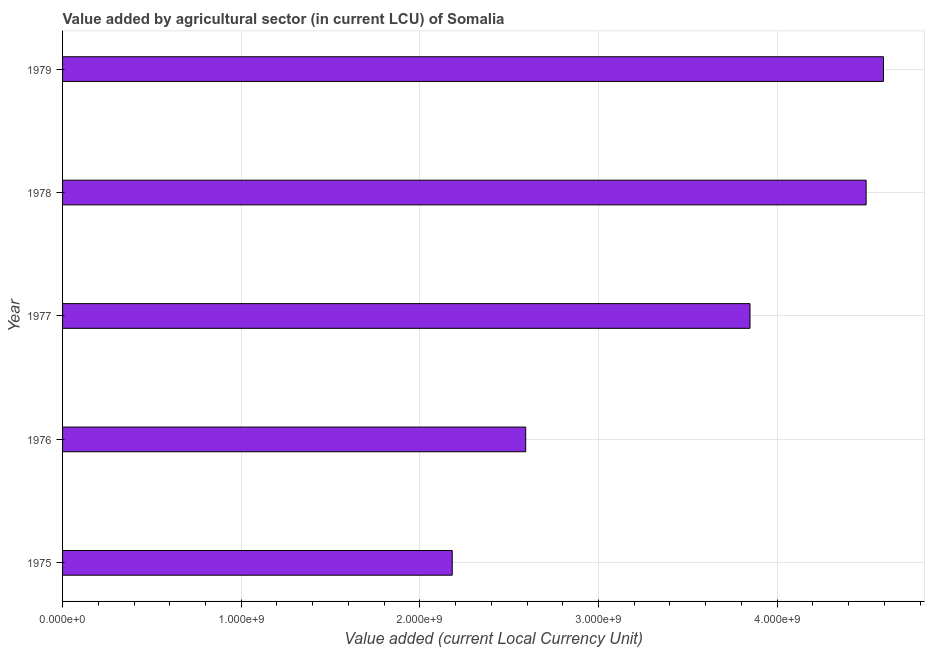What is the title of the graph?
Provide a succinct answer. Value added by agricultural sector (in current LCU) of Somalia. What is the label or title of the X-axis?
Offer a very short reply. Value added (current Local Currency Unit). What is the label or title of the Y-axis?
Offer a terse response. Year. What is the value added by agriculture sector in 1979?
Make the answer very short. 4.59e+09. Across all years, what is the maximum value added by agriculture sector?
Provide a succinct answer. 4.59e+09. Across all years, what is the minimum value added by agriculture sector?
Provide a short and direct response. 2.18e+09. In which year was the value added by agriculture sector maximum?
Your answer should be very brief. 1979. In which year was the value added by agriculture sector minimum?
Give a very brief answer. 1975. What is the sum of the value added by agriculture sector?
Your answer should be very brief. 1.77e+1. What is the difference between the value added by agriculture sector in 1977 and 1979?
Make the answer very short. -7.47e+08. What is the average value added by agriculture sector per year?
Provide a short and direct response. 3.54e+09. What is the median value added by agriculture sector?
Ensure brevity in your answer.  3.85e+09. Do a majority of the years between 1977 and 1976 (inclusive) have value added by agriculture sector greater than 1000000000 LCU?
Your response must be concise. No. What is the ratio of the value added by agriculture sector in 1976 to that in 1977?
Provide a short and direct response. 0.67. Is the value added by agriculture sector in 1978 less than that in 1979?
Your answer should be compact. Yes. Is the difference between the value added by agriculture sector in 1975 and 1976 greater than the difference between any two years?
Keep it short and to the point. No. What is the difference between the highest and the second highest value added by agriculture sector?
Provide a short and direct response. 9.70e+07. What is the difference between the highest and the lowest value added by agriculture sector?
Offer a terse response. 2.41e+09. How many bars are there?
Your answer should be compact. 5. How many years are there in the graph?
Make the answer very short. 5. What is the difference between two consecutive major ticks on the X-axis?
Provide a succinct answer. 1.00e+09. What is the Value added (current Local Currency Unit) of 1975?
Provide a short and direct response. 2.18e+09. What is the Value added (current Local Currency Unit) of 1976?
Provide a short and direct response. 2.59e+09. What is the Value added (current Local Currency Unit) of 1977?
Provide a succinct answer. 3.85e+09. What is the Value added (current Local Currency Unit) in 1978?
Your answer should be compact. 4.50e+09. What is the Value added (current Local Currency Unit) of 1979?
Keep it short and to the point. 4.59e+09. What is the difference between the Value added (current Local Currency Unit) in 1975 and 1976?
Keep it short and to the point. -4.11e+08. What is the difference between the Value added (current Local Currency Unit) in 1975 and 1977?
Ensure brevity in your answer.  -1.67e+09. What is the difference between the Value added (current Local Currency Unit) in 1975 and 1978?
Your answer should be compact. -2.32e+09. What is the difference between the Value added (current Local Currency Unit) in 1975 and 1979?
Your answer should be compact. -2.41e+09. What is the difference between the Value added (current Local Currency Unit) in 1976 and 1977?
Make the answer very short. -1.26e+09. What is the difference between the Value added (current Local Currency Unit) in 1976 and 1978?
Ensure brevity in your answer.  -1.91e+09. What is the difference between the Value added (current Local Currency Unit) in 1976 and 1979?
Keep it short and to the point. -2.00e+09. What is the difference between the Value added (current Local Currency Unit) in 1977 and 1978?
Your answer should be very brief. -6.50e+08. What is the difference between the Value added (current Local Currency Unit) in 1977 and 1979?
Your response must be concise. -7.47e+08. What is the difference between the Value added (current Local Currency Unit) in 1978 and 1979?
Your answer should be compact. -9.70e+07. What is the ratio of the Value added (current Local Currency Unit) in 1975 to that in 1976?
Offer a terse response. 0.84. What is the ratio of the Value added (current Local Currency Unit) in 1975 to that in 1977?
Make the answer very short. 0.57. What is the ratio of the Value added (current Local Currency Unit) in 1975 to that in 1978?
Keep it short and to the point. 0.48. What is the ratio of the Value added (current Local Currency Unit) in 1975 to that in 1979?
Your answer should be very brief. 0.47. What is the ratio of the Value added (current Local Currency Unit) in 1976 to that in 1977?
Offer a terse response. 0.67. What is the ratio of the Value added (current Local Currency Unit) in 1976 to that in 1978?
Provide a short and direct response. 0.58. What is the ratio of the Value added (current Local Currency Unit) in 1976 to that in 1979?
Make the answer very short. 0.56. What is the ratio of the Value added (current Local Currency Unit) in 1977 to that in 1978?
Give a very brief answer. 0.85. What is the ratio of the Value added (current Local Currency Unit) in 1977 to that in 1979?
Provide a short and direct response. 0.84. What is the ratio of the Value added (current Local Currency Unit) in 1978 to that in 1979?
Keep it short and to the point. 0.98. 